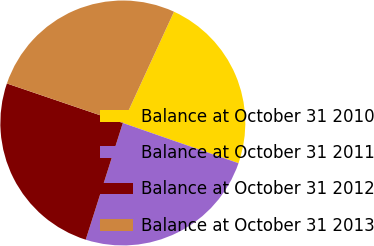Convert chart. <chart><loc_0><loc_0><loc_500><loc_500><pie_chart><fcel>Balance at October 31 2010<fcel>Balance at October 31 2011<fcel>Balance at October 31 2012<fcel>Balance at October 31 2013<nl><fcel>23.47%<fcel>24.57%<fcel>25.33%<fcel>26.63%<nl></chart> 